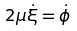Convert formula to latex. <formula><loc_0><loc_0><loc_500><loc_500>2 \mu \dot { \xi } = \dot { \phi } \</formula> 